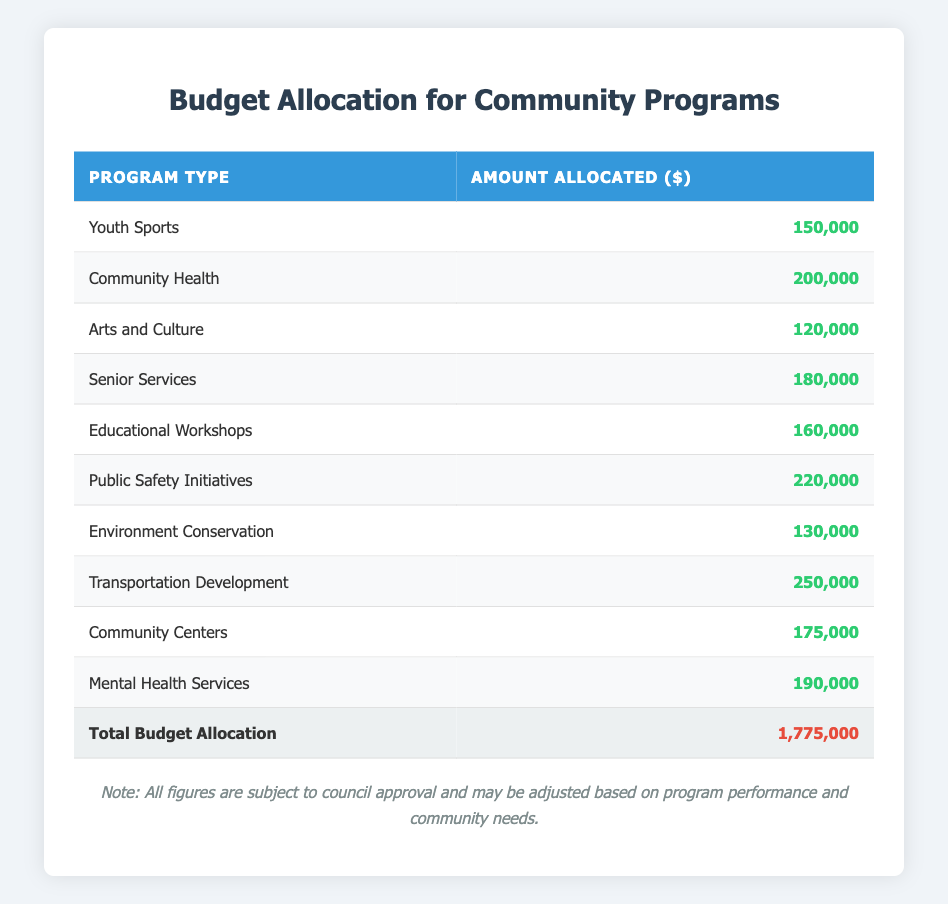What is the total amount allocated for Community Health programs? The table shows that the amount allocated for Community Health is listed directly next to it, which is $200,000.
Answer: 200,000 Which program type received the highest allocation? By examining the amounts allocated for each program type, Transportation Development has the highest allocation at $250,000.
Answer: Transportation Development What is the difference in allocation between Public Safety Initiatives and Arts and Culture? Public Safety Initiatives received $220,000 and Arts and Culture received $120,000. The difference is calculated as $220,000 - $120,000 = $100,000.
Answer: 100,000 Is the amount allocated for Senior Services greater than the amount for Educational Workshops? Senior Services received $180,000, while Educational Workshops received $160,000, so $180,000 is greater than $160,000. Therefore, the statement is true.
Answer: Yes What is the average allocation amount across all program types? First, sum all the allocations: 150,000 + 200,000 + 120,000 + 180,000 + 160,000 + 220,000 + 130,000 + 250,000 + 175,000 + 190,000 = 1,775,000. Then divide by the number of program types (10): 1,775,000 / 10 = 177,500.
Answer: 177,500 